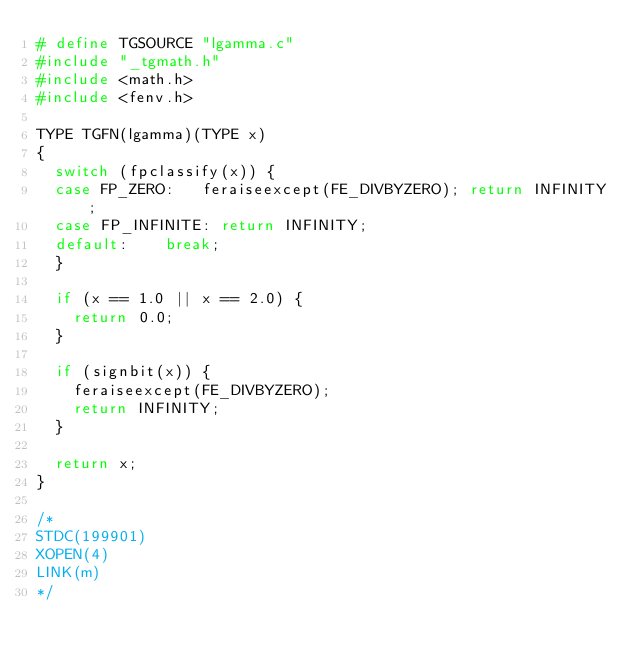<code> <loc_0><loc_0><loc_500><loc_500><_C_># define TGSOURCE "lgamma.c"
#include "_tgmath.h"
#include <math.h>
#include <fenv.h>

TYPE TGFN(lgamma)(TYPE x)
{
	switch (fpclassify(x)) {
	case FP_ZERO:		feraiseexcept(FE_DIVBYZERO); return INFINITY;
	case FP_INFINITE:	return INFINITY;
	default:		break;
	}

	if (x == 1.0 || x == 2.0) {
		return 0.0;
	}

	if (signbit(x)) {
		feraiseexcept(FE_DIVBYZERO);
		return INFINITY;
	}

	return x;
}

/*
STDC(199901)
XOPEN(4)
LINK(m)
*/
</code> 